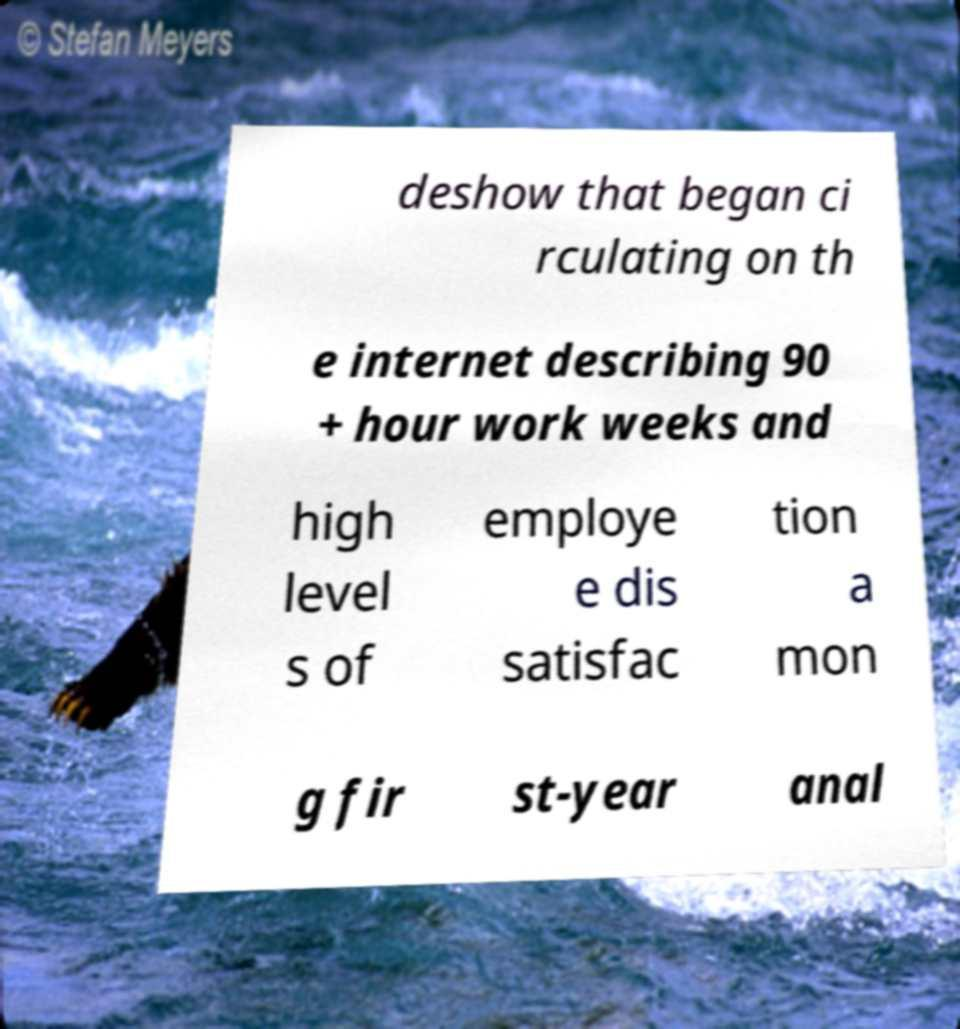For documentation purposes, I need the text within this image transcribed. Could you provide that? deshow that began ci rculating on th e internet describing 90 + hour work weeks and high level s of employe e dis satisfac tion a mon g fir st-year anal 